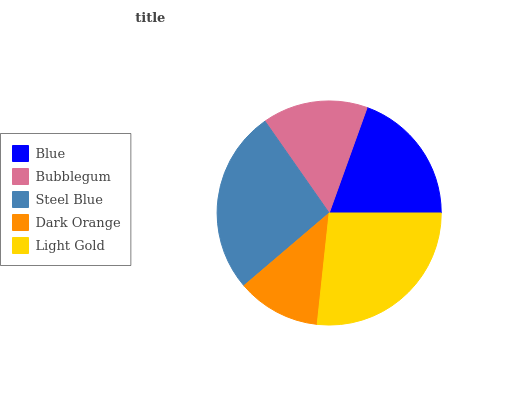Is Dark Orange the minimum?
Answer yes or no. Yes. Is Light Gold the maximum?
Answer yes or no. Yes. Is Bubblegum the minimum?
Answer yes or no. No. Is Bubblegum the maximum?
Answer yes or no. No. Is Blue greater than Bubblegum?
Answer yes or no. Yes. Is Bubblegum less than Blue?
Answer yes or no. Yes. Is Bubblegum greater than Blue?
Answer yes or no. No. Is Blue less than Bubblegum?
Answer yes or no. No. Is Blue the high median?
Answer yes or no. Yes. Is Blue the low median?
Answer yes or no. Yes. Is Bubblegum the high median?
Answer yes or no. No. Is Steel Blue the low median?
Answer yes or no. No. 